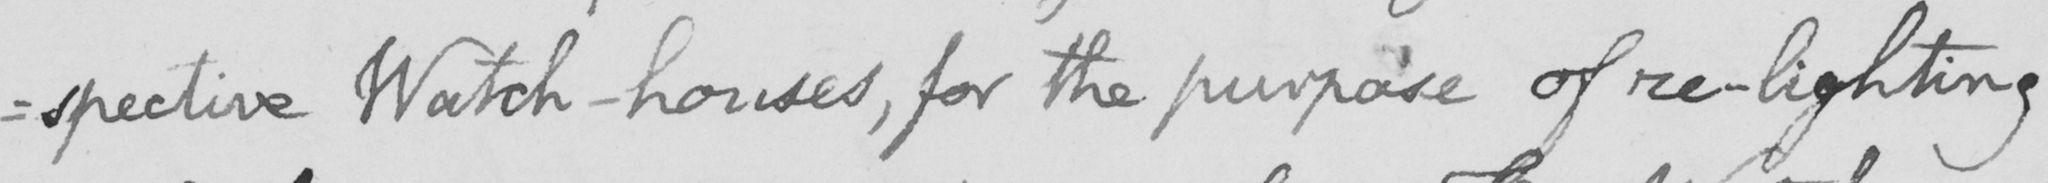Transcribe the text shown in this historical manuscript line. : spective Watch-houses , for the purpose of re-lighting 